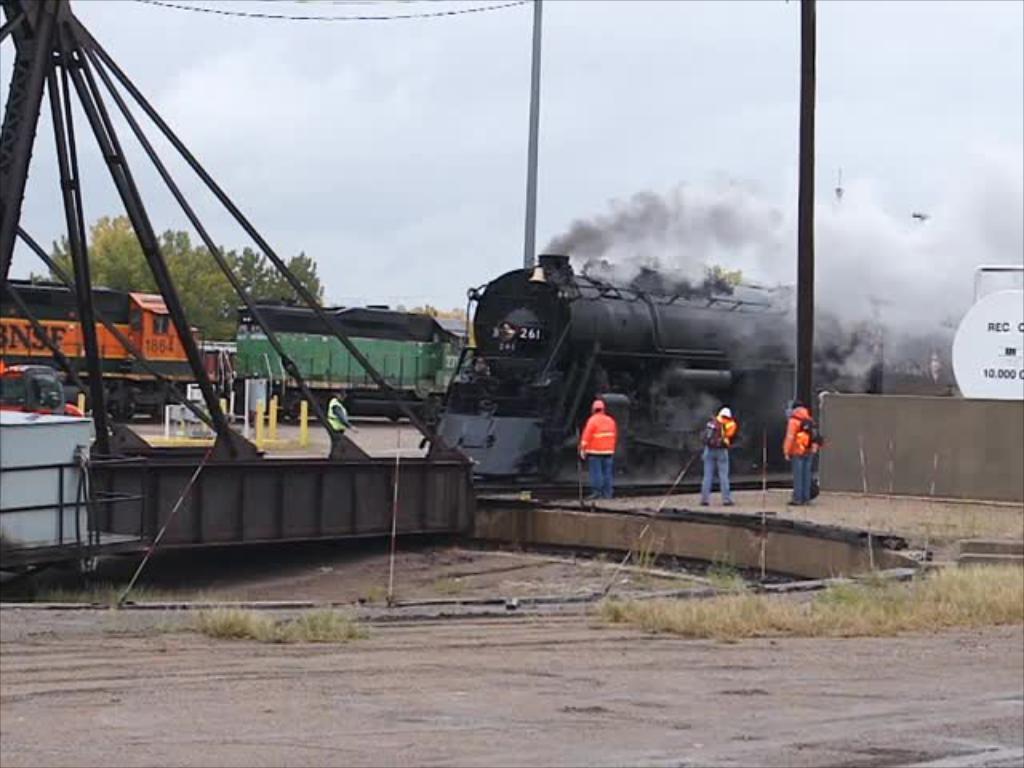Can you describe this image briefly? In this image, we can see three persons wearing clothes and standing in front of the train. There is a metal frame, train and tree on the left side of the image. There are poles in the middle of the image. There is a sky at the top of the image. 